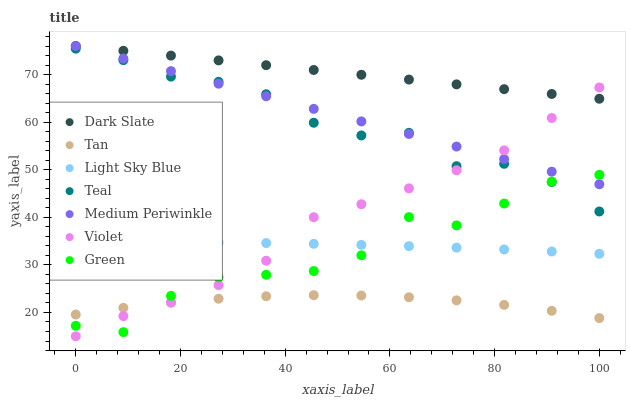Does Tan have the minimum area under the curve?
Answer yes or no. Yes. Does Dark Slate have the maximum area under the curve?
Answer yes or no. Yes. Does Light Sky Blue have the minimum area under the curve?
Answer yes or no. No. Does Light Sky Blue have the maximum area under the curve?
Answer yes or no. No. Is Dark Slate the smoothest?
Answer yes or no. Yes. Is Green the roughest?
Answer yes or no. Yes. Is Light Sky Blue the smoothest?
Answer yes or no. No. Is Light Sky Blue the roughest?
Answer yes or no. No. Does Violet have the lowest value?
Answer yes or no. Yes. Does Light Sky Blue have the lowest value?
Answer yes or no. No. Does Dark Slate have the highest value?
Answer yes or no. Yes. Does Light Sky Blue have the highest value?
Answer yes or no. No. Is Tan less than Dark Slate?
Answer yes or no. Yes. Is Medium Periwinkle greater than Tan?
Answer yes or no. Yes. Does Green intersect Medium Periwinkle?
Answer yes or no. Yes. Is Green less than Medium Periwinkle?
Answer yes or no. No. Is Green greater than Medium Periwinkle?
Answer yes or no. No. Does Tan intersect Dark Slate?
Answer yes or no. No. 